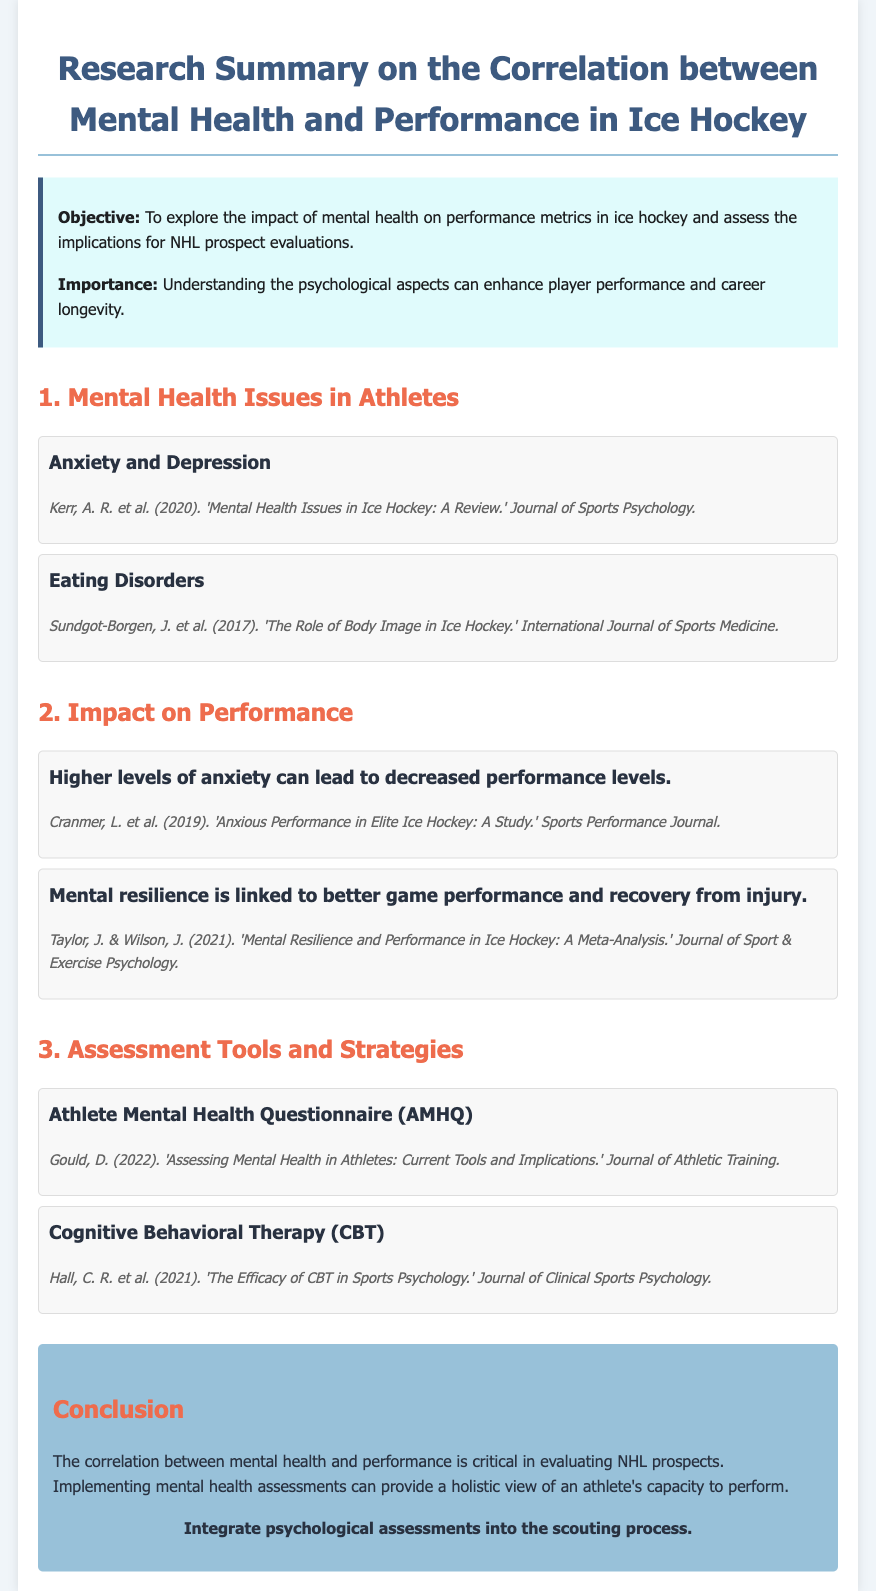What is the objective of the research? The objective is to explore the impact of mental health on performance metrics in ice hockey.
Answer: To explore the impact of mental health on performance metrics in ice hockey What are two mental health issues mentioned? The document lists "Anxiety and Depression" and "Eating Disorders" as mental health issues in athletes.
Answer: Anxiety and Depression, Eating Disorders Which assessment tool is mentioned for mental health evaluation? The document refers to the "Athlete Mental Health Questionnaire (AMHQ)" as a tool for evaluation.
Answer: Athlete Mental Health Questionnaire (AMHQ) What is linked to better game performance according to the document? The document states that "Mental resilience" is linked to better game performance and recovery.
Answer: Mental resilience What year was the study on anxious performance published? The study titled "Anxious Performance in Elite Ice Hockey" was published in 2019.
Answer: 2019 How many key points are listed under "Impact on Performance"? There are two key points listed in the "Impact on Performance" section.
Answer: Two What is the call-to-action in the conclusion? The conclusion includes a call-to-action to "Integrate psychological assessments into the scouting process."
Answer: Integrate psychological assessments into the scouting process Which author is associated with the study on CBT efficacy? The document mentions "Hall, C. R. et al." as the authors associated with the study on CBT efficacy.
Answer: Hall, C. R. et al 